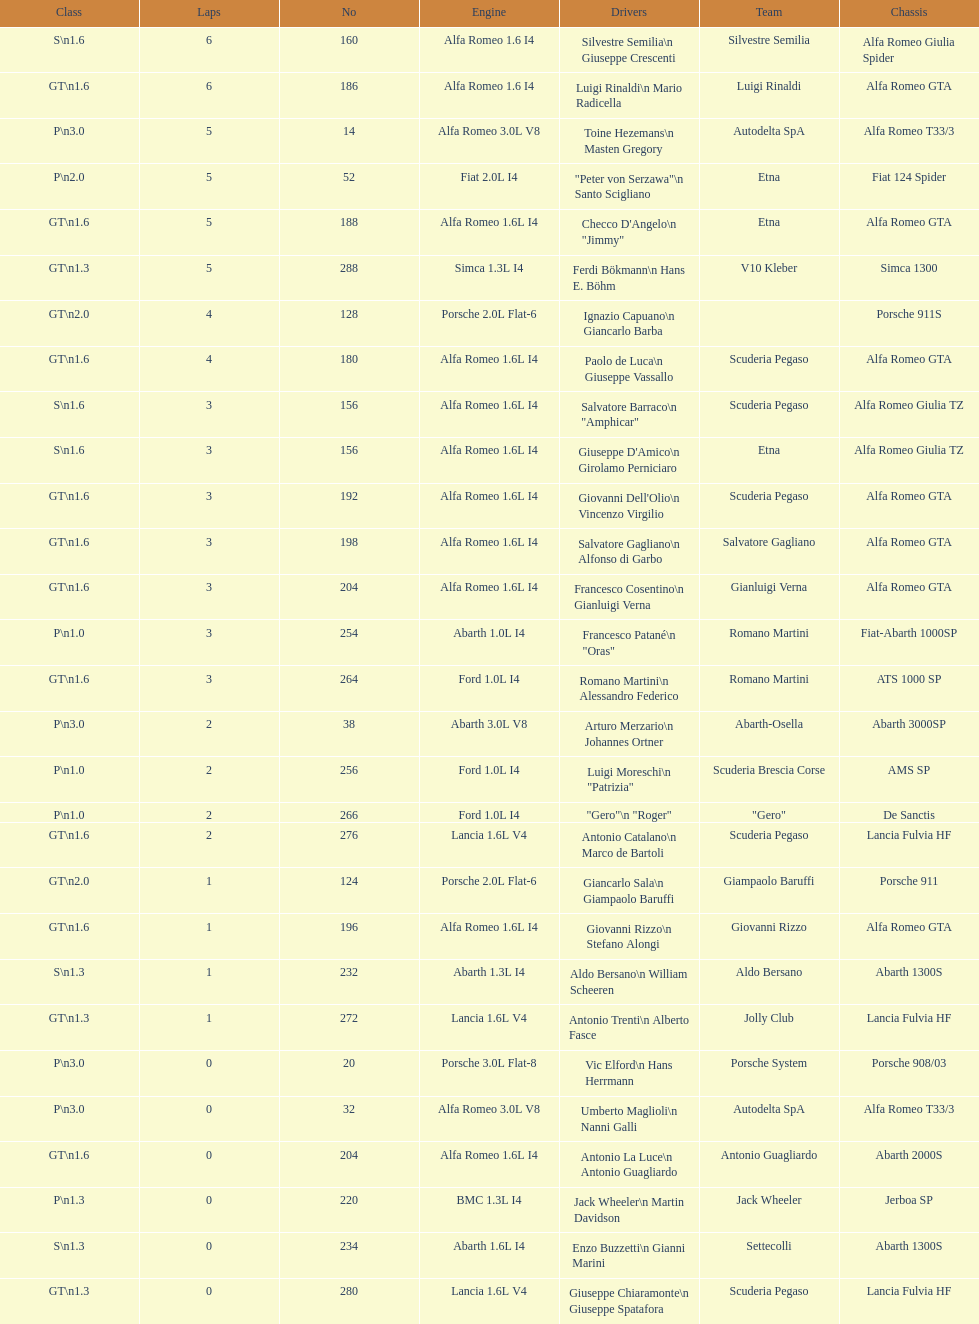How many teams failed to finish the race after 2 laps? 4. 